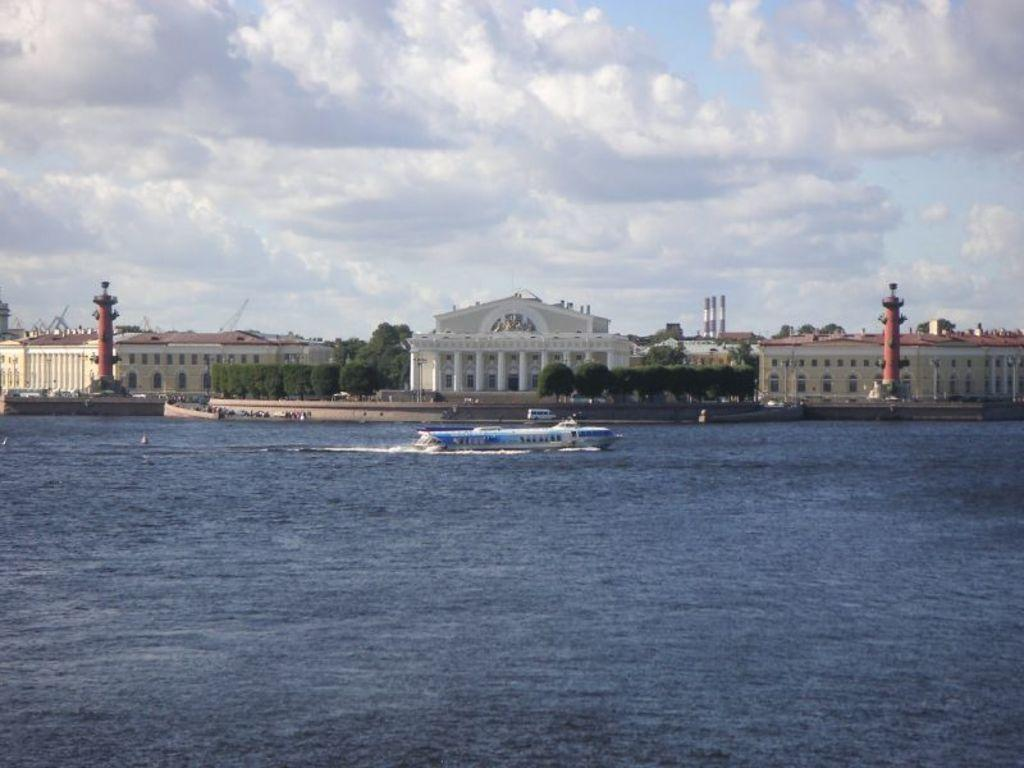What is the main subject of the image? The main subject of the image is a boat. Where is the boat located? The boat is on water. What can be seen in the background of the image? In the background of the image, there are buildings, trees, a vehicle, the sky, clouds, and some unspecified objects. Can you describe the sky in the image? The sky is visible in the background of the image, and there are clouds present. What type of songs can be heard coming from the boat in the image? There is no indication in the image that any songs are being played or heard from the boat. 